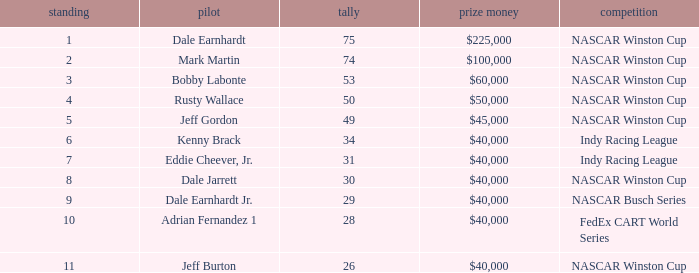In what position was the driver who won $60,000? 3.0. 